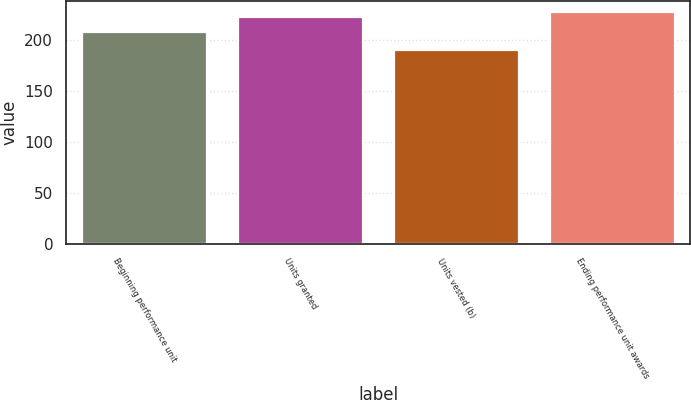<chart> <loc_0><loc_0><loc_500><loc_500><bar_chart><fcel>Beginning performance unit<fcel>Units granted<fcel>Units vested (b)<fcel>Ending performance unit awards<nl><fcel>207.88<fcel>222.33<fcel>189.71<fcel>226.74<nl></chart> 